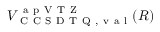Convert formula to latex. <formula><loc_0><loc_0><loc_500><loc_500>V _ { C C S D T Q , v a l } ^ { a p V T Z } ( R )</formula> 